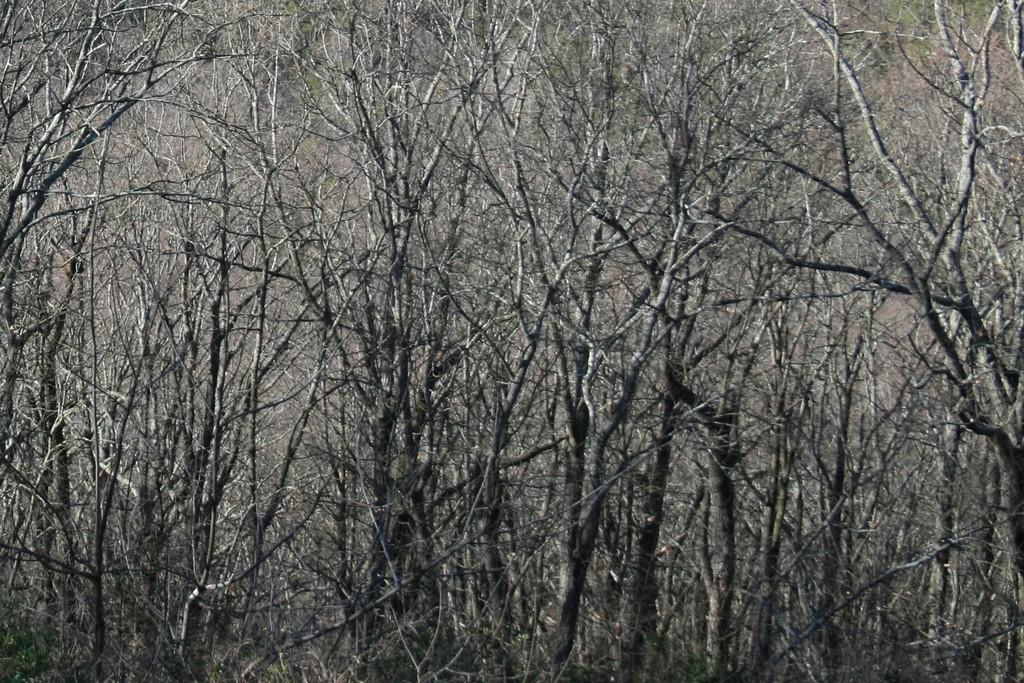What type of trees can be seen in the image? There are dried trees in the image. What is the condition of the trees in the image? The trees have no leaves. Where are the trees located in the image? The trees are on the ground. What type of smile can be seen on the trees in the image? There are no smiles present on the trees in the image, as they are dried trees with no leaves. 